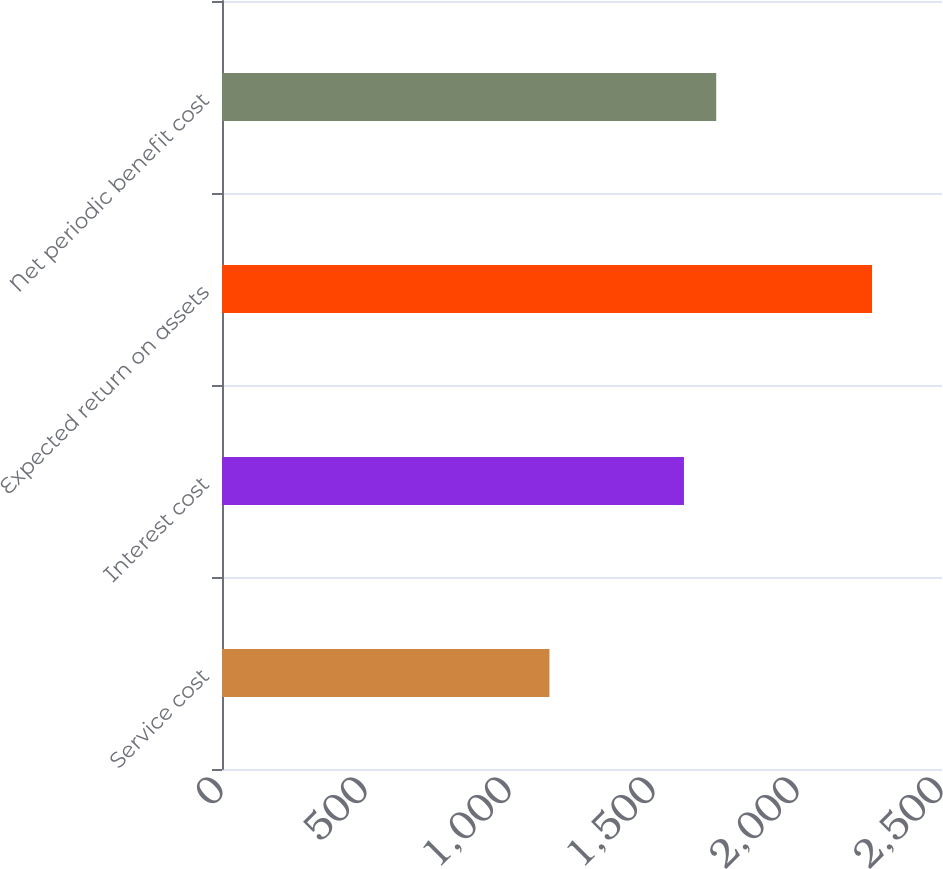Convert chart. <chart><loc_0><loc_0><loc_500><loc_500><bar_chart><fcel>Service cost<fcel>Interest cost<fcel>Expected return on assets<fcel>Net periodic benefit cost<nl><fcel>1137<fcel>1604<fcel>2257<fcel>1716<nl></chart> 